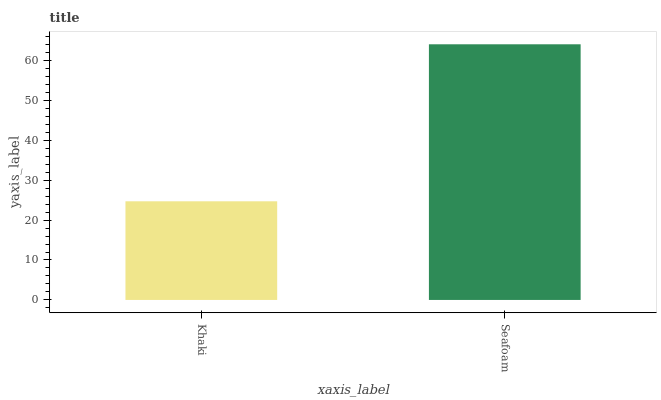Is Seafoam the minimum?
Answer yes or no. No. Is Seafoam greater than Khaki?
Answer yes or no. Yes. Is Khaki less than Seafoam?
Answer yes or no. Yes. Is Khaki greater than Seafoam?
Answer yes or no. No. Is Seafoam less than Khaki?
Answer yes or no. No. Is Seafoam the high median?
Answer yes or no. Yes. Is Khaki the low median?
Answer yes or no. Yes. Is Khaki the high median?
Answer yes or no. No. Is Seafoam the low median?
Answer yes or no. No. 